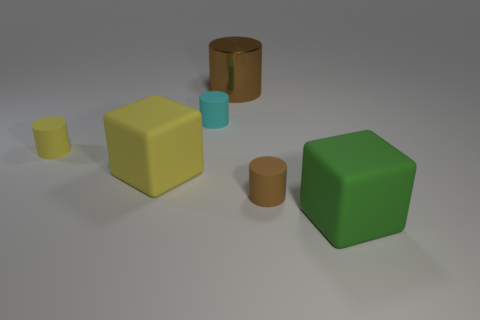There is a large block that is left of the big green thing; are there any tiny cylinders in front of it? Indeed, there are two small cylinders positioned in front of the large yellow block. One is shorter and wider, and the other is taller and narrower. Both of them display a brown hue reminiscent of earthenware. 